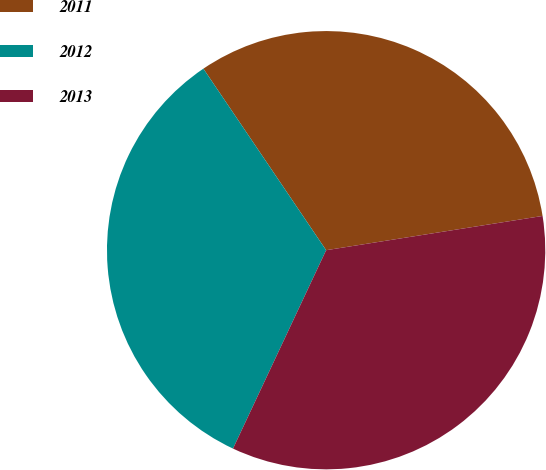Convert chart. <chart><loc_0><loc_0><loc_500><loc_500><pie_chart><fcel>2011<fcel>2012<fcel>2013<nl><fcel>31.96%<fcel>33.55%<fcel>34.48%<nl></chart> 